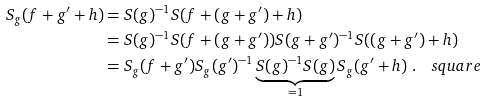<formula> <loc_0><loc_0><loc_500><loc_500>S _ { g } ( f + g ^ { \prime } + h ) & = S ( g ) ^ { - 1 } S ( f + ( g + g ^ { \prime } ) + h ) \\ & = S ( g ) ^ { - 1 } S ( f + ( g + g ^ { \prime } ) ) S ( g + g ^ { \prime } ) ^ { - 1 } S ( ( g + g ^ { \prime } ) + h ) \\ & = S _ { g } ( f + g ^ { \prime } ) S _ { g } ( g ^ { \prime } ) ^ { - 1 } \underbrace { S ( g ) ^ { - 1 } S ( g ) } _ { = 1 } S _ { g } ( g ^ { \prime } + h ) \ . \quad s q u a r e</formula> 